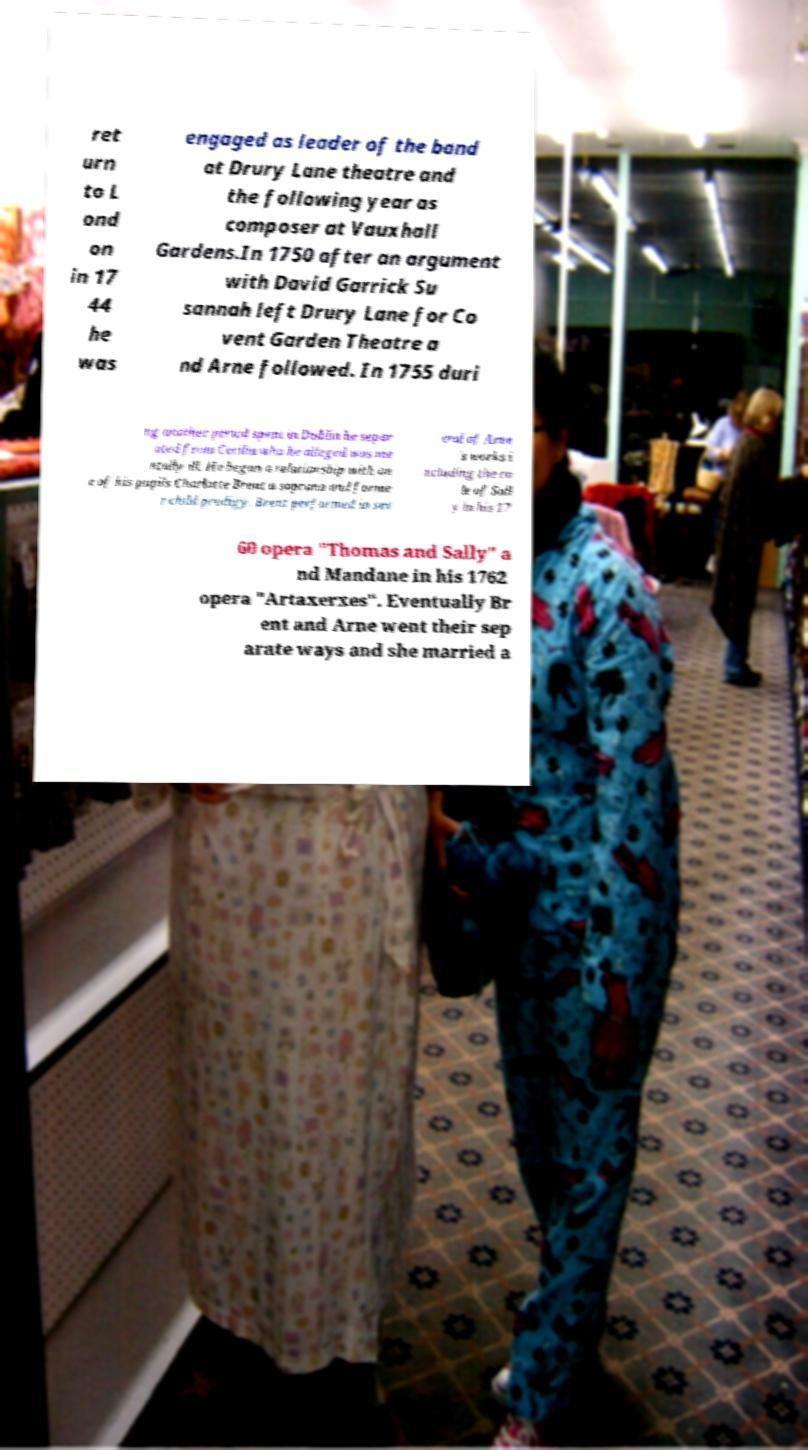Can you accurately transcribe the text from the provided image for me? ret urn to L ond on in 17 44 he was engaged as leader of the band at Drury Lane theatre and the following year as composer at Vauxhall Gardens.In 1750 after an argument with David Garrick Su sannah left Drury Lane for Co vent Garden Theatre a nd Arne followed. In 1755 duri ng another period spent in Dublin he separ ated from Cecilia who he alleged was me ntally ill. He began a relationship with on e of his pupils Charlotte Brent a soprano and forme r child prodigy. Brent performed in sev eral of Arne 's works i ncluding the ro le of Sall y in his 17 60 opera "Thomas and Sally" a nd Mandane in his 1762 opera "Artaxerxes". Eventually Br ent and Arne went their sep arate ways and she married a 